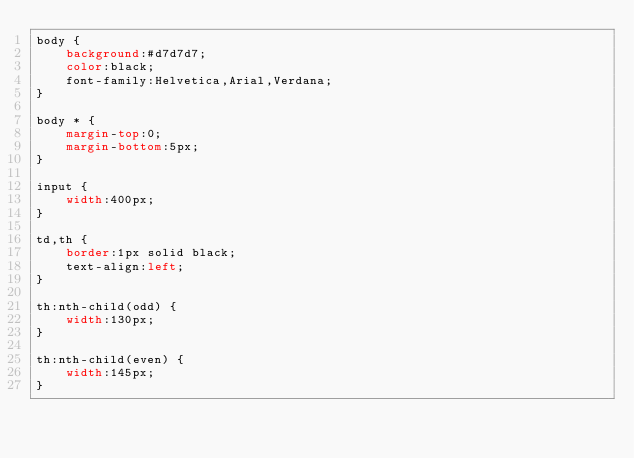Convert code to text. <code><loc_0><loc_0><loc_500><loc_500><_CSS_>body {
    background:#d7d7d7;
    color:black;
    font-family:Helvetica,Arial,Verdana;
}

body * {
    margin-top:0;
    margin-bottom:5px;
}

input {
    width:400px;
}

td,th {
    border:1px solid black;
    text-align:left;
}

th:nth-child(odd) {
    width:130px;
}

th:nth-child(even) {
    width:145px;
}</code> 